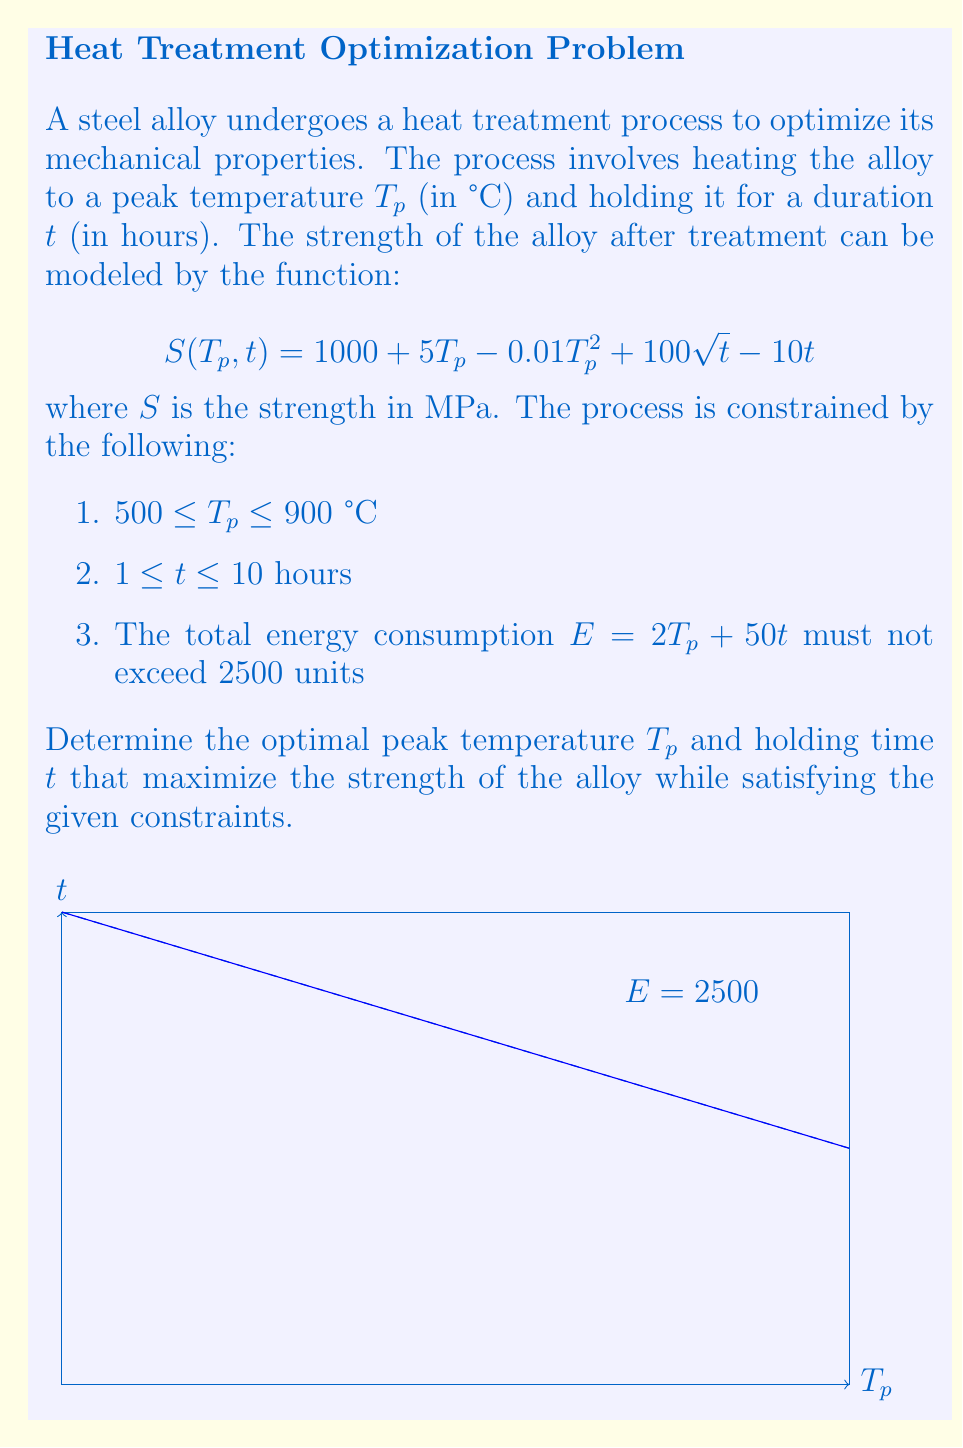Give your solution to this math problem. To solve this optimization problem, we'll use the method of Lagrange multipliers:

1) First, let's form the Lagrangian function:
   $$L(T_p, t, \lambda) = S(T_p, t) - \lambda(2T_p + 50t - 2500)$$

2) Now, we calculate the partial derivatives and set them to zero:
   $$\frac{\partial L}{\partial T_p} = 5 - 0.02T_p - 2\lambda = 0$$
   $$\frac{\partial L}{\partial t} = \frac{50}{\sqrt{t}} - 10 - 50\lambda = 0$$
   $$\frac{\partial L}{\partial \lambda} = 2T_p + 50t - 2500 = 0$$

3) From the first equation:
   $$T_p = 250 - 100\lambda$$

4) From the second equation:
   $$\frac{50}{\sqrt{t}} = 10 + 50\lambda$$
   $$t = \frac{2500}{(10 + 50\lambda)^2}$$

5) Substituting these into the third equation:
   $$2(250 - 100\lambda) + 50(\frac{2500}{(10 + 50\lambda)^2}) - 2500 = 0$$

6) This equation can be solved numerically. Using a numerical solver, we get:
   $$\lambda \approx 0.0191$$

7) Substituting this back:
   $$T_p \approx 748.1°C$$
   $$t \approx 5.0 \text{ hours}$$

8) We need to check if these values satisfy the constraints:
   - $500 \leq 748.1 \leq 900$ (✓)
   - $1 \leq 5.0 \leq 10$ (✓)
   - $2(748.1) + 50(5.0) = 1746.2 \leq 2500$ (✓)

9) Finally, we calculate the strength:
   $$S(748.1, 5.0) \approx 1598.4 \text{ MPa}$$

This is the maximum strength achievable within the given constraints.
Answer: $T_p \approx 748.1°C$, $t \approx 5.0 \text{ hours}$ 